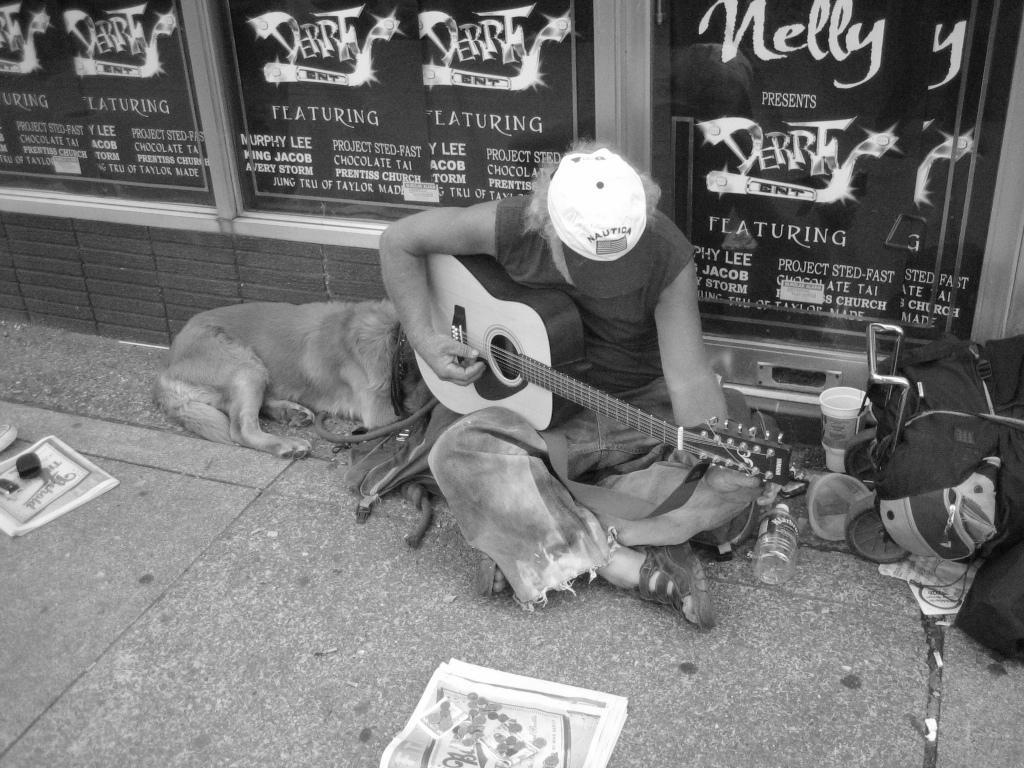Describe this image in one or two sentences. This is a black and white picture. The man is sitting on a floor and playing guitar. Beside the man there is a dog lying on the floor. To the right side of the man there are bottle, caps and some items. In front of the man there are papers on the floor. Behind the man there are hoardings and a wall. 